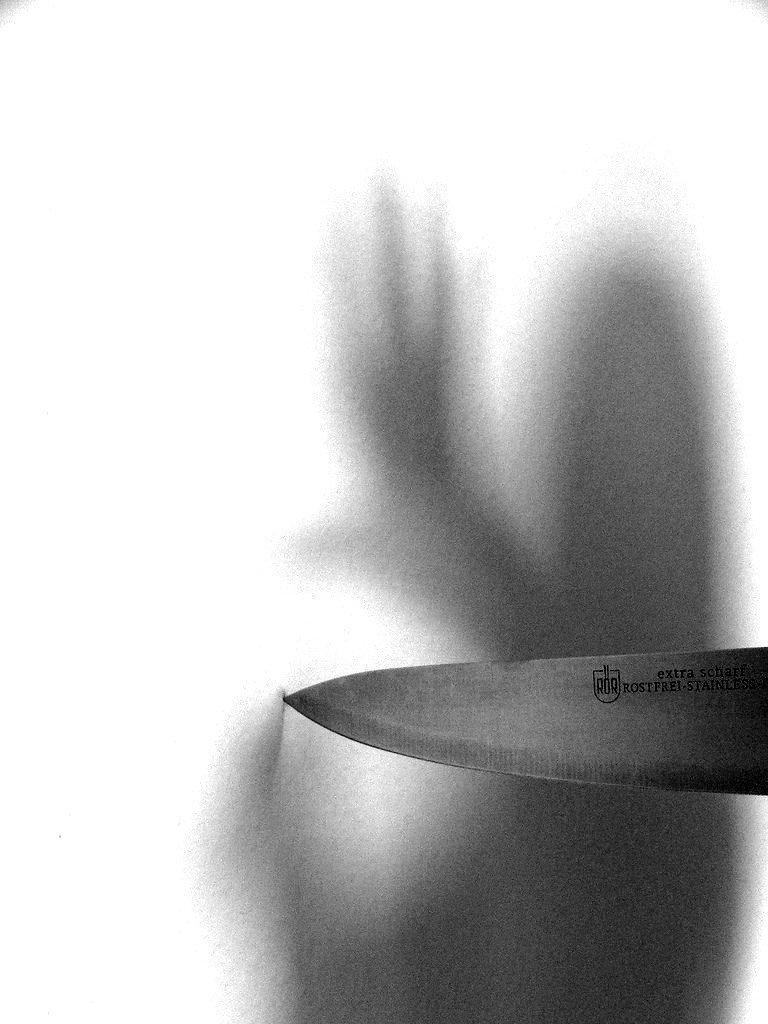Describe this image in one or two sentences. In this image we can see a knife and a shadow. 